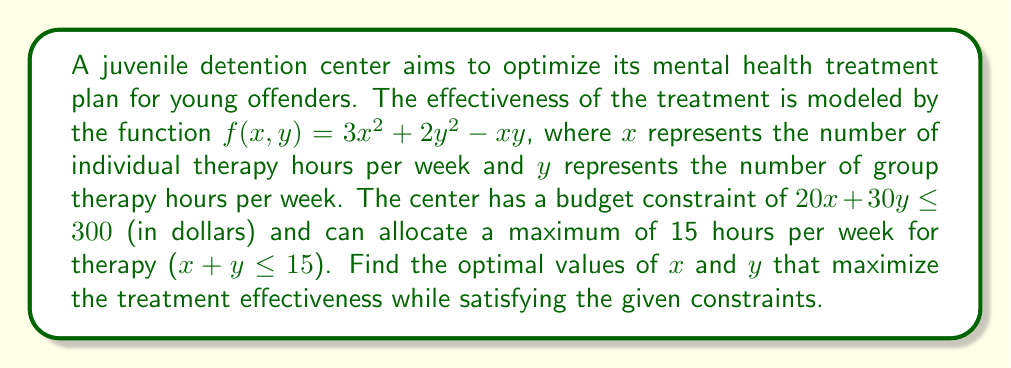Help me with this question. To solve this constrained optimization problem, we'll use the method of Lagrange multipliers:

1) Let's define the Lagrangian function:
   $$L(x, y, \lambda_1, \lambda_2) = f(x, y) - \lambda_1(20x + 30y - 300) - \lambda_2(x + y - 15)$$

2) Now, we need to find the partial derivatives and set them to zero:

   $$\frac{\partial L}{\partial x} = 6x - y - 20\lambda_1 - \lambda_2 = 0$$
   $$\frac{\partial L}{\partial y} = 4y - x - 30\lambda_1 - \lambda_2 = 0$$
   $$\frac{\partial L}{\partial \lambda_1} = 20x + 30y - 300 = 0$$
   $$\frac{\partial L}{\partial \lambda_2} = x + y - 15 = 0$$

3) From the last equation: $y = 15 - x$

4) Substituting this into the first two equations:
   $$6x - (15 - x) - 20\lambda_1 - \lambda_2 = 0$$
   $$4(15 - x) - x - 30\lambda_1 - \lambda_2 = 0$$

5) Subtracting the second equation from the first:
   $$7x - 60 + 10\lambda_1 = 0$$
   $$x = \frac{60 - 10\lambda_1}{7}$$

6) Substituting this into the third equation:
   $$20(\frac{60 - 10\lambda_1}{7}) + 30(15 - \frac{60 - 10\lambda_1}{7}) = 300$$

7) Solving this equation:
   $$\lambda_1 = \frac{15}{7}$$

8) Therefore:
   $$x = \frac{60 - 10(\frac{15}{7})}{7} = \frac{270}{49} \approx 5.51$$
   $$y = 15 - \frac{270}{49} = \frac{465}{49} \approx 9.49$$

9) We need to check if this solution satisfies the budget constraint:
   $$20(5.51) + 30(9.49) \approx 395.10 > 300$$

   It doesn't, so the optimal solution must lie on the budget constraint boundary.

10) Solving the system of equations:
    $$20x + 30y = 300$$
    $$x + y = 15$$

    We get: $x = 7.5$ and $y = 7.5$

11) This solution satisfies both constraints and is therefore the optimal solution.
Answer: $x = 7.5$, $y = 7.5$ 